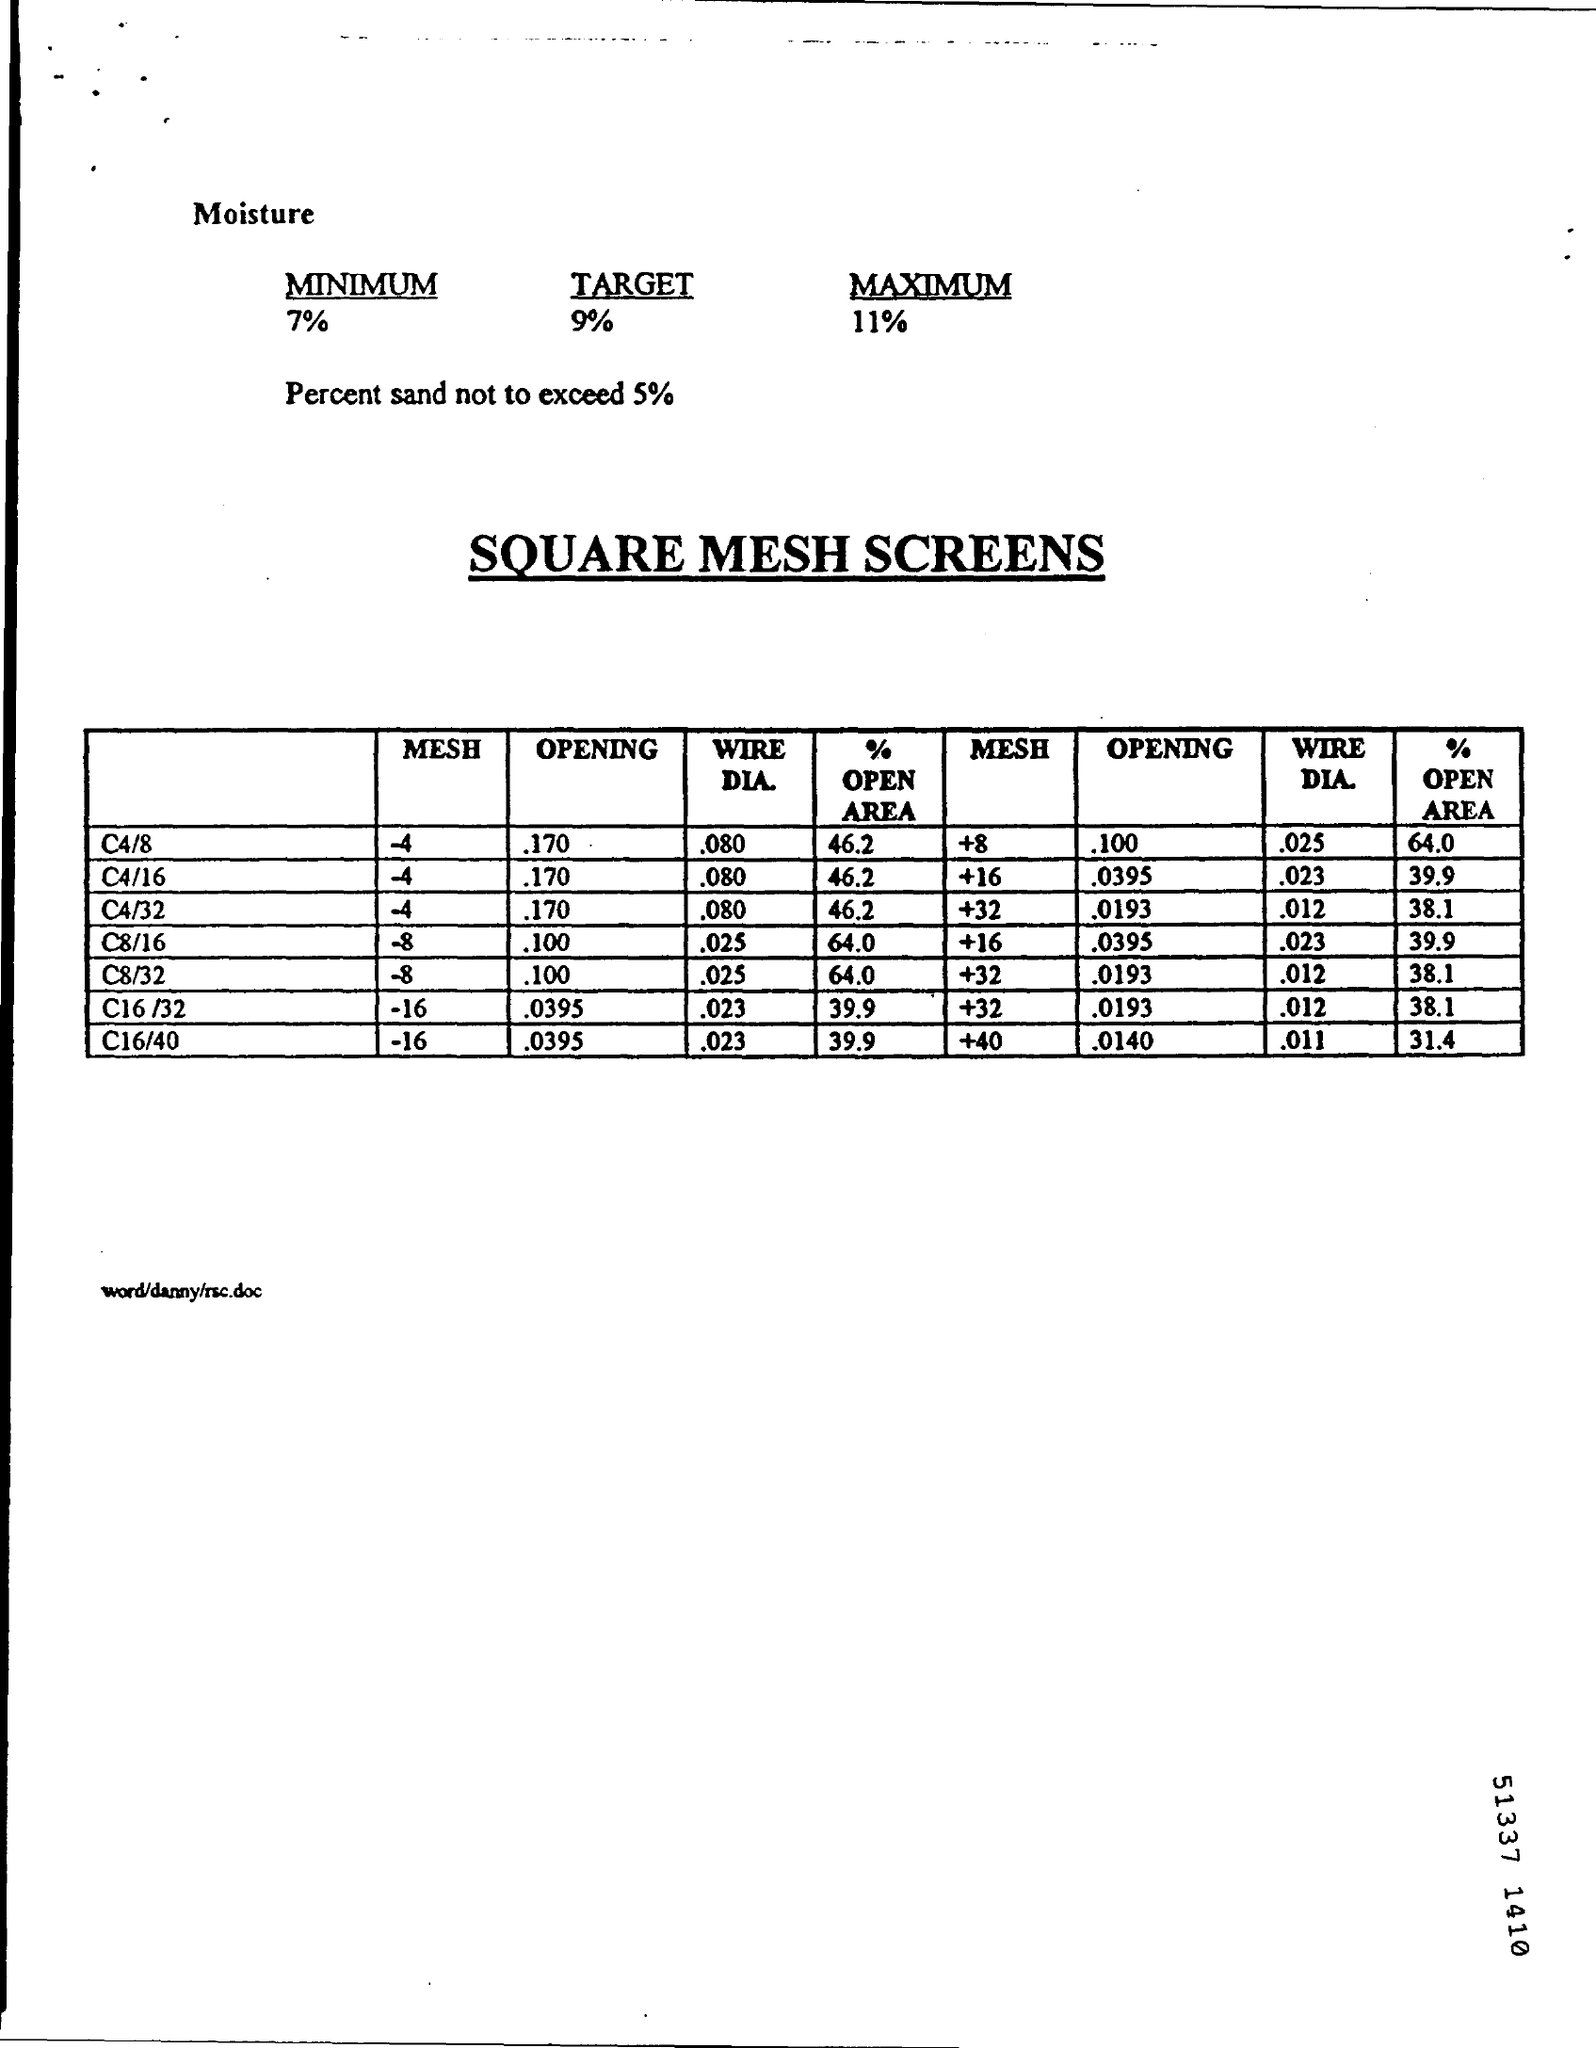What is the target moisture?
Offer a terse response. 9. What is the maximum percent sand?
Give a very brief answer. 5%. What is the opening of C4/8 of mesh -4?
Give a very brief answer. .170. What is the heading of the table?
Your response must be concise. SQUARE MESH SCREENS. 